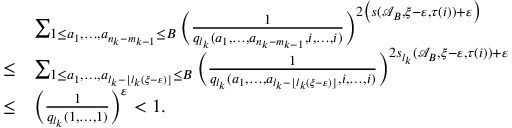Convert formula to latex. <formula><loc_0><loc_0><loc_500><loc_500>\begin{array} { r l } & { \sum _ { 1 \leq a _ { 1 } , \dots , a _ { n _ { k } - m _ { k - 1 } } \leq B } \left ( \frac { 1 } { q _ { l _ { k } } ( a _ { 1 } , \dots , a _ { n _ { k } - m _ { k - 1 } } , i , \dots , i ) } \right ) ^ { 2 \left ( s ( \mathcal { A } _ { B } , \xi - \varepsilon , \tau ( i ) ) + \varepsilon \right ) } } \\ { \leq } & { \sum _ { 1 \leq a _ { 1 } , \dots , a _ { l _ { k } - \lfloor l _ { k } ( \xi - \varepsilon ) \rfloor } \leq B } \left ( \frac { 1 } { q _ { l _ { k } } ( a _ { 1 } , \dots , a _ { l _ { k } - \lfloor l _ { k } ( \xi - \varepsilon ) \rfloor } , i , \dots , i ) } \right ) ^ { 2 s _ { l _ { k } } ( \mathcal { A } _ { B } , \xi - \varepsilon , \tau ( i ) ) + \varepsilon } } \\ { \leq } & { \left ( \frac { 1 } { q _ { l _ { k } } ( 1 , \dots , 1 ) } \right ) ^ { \varepsilon } < 1 . } \end{array}</formula> 